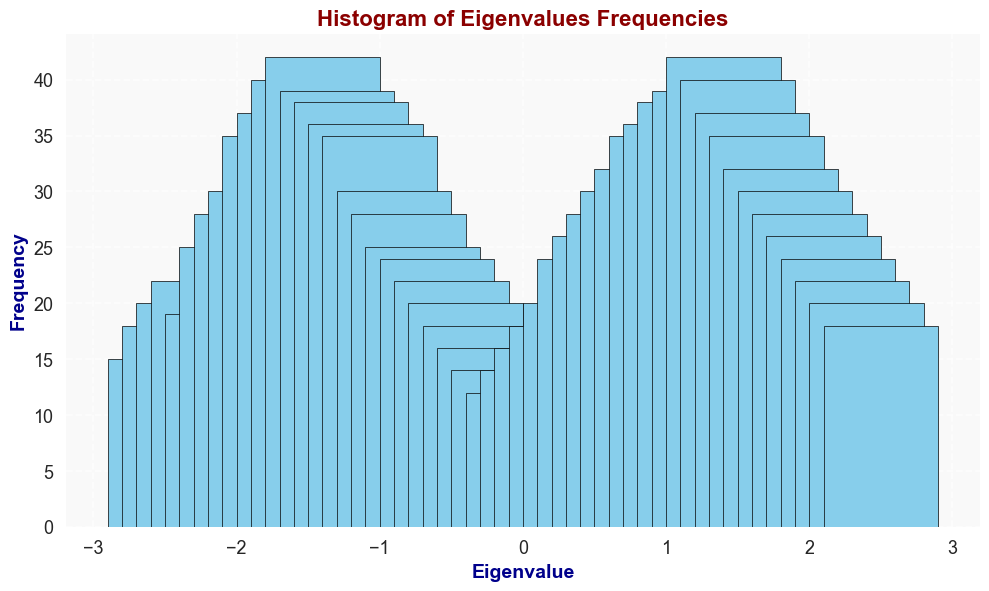what is the most frequent eigenvalue range in the histogram? To find the most frequent eigenvalue range, look for the bar with the highest frequency on the Y-axis. The highest bar corresponds to eigenvalue ranges -1.4 and 1.4, with a frequency of 42.
Answer: -1.4 and 1.4 Which eigenvalue has a frequency closest to 30? To answer this, observe which eigenvalues have bars near 30 on the Y-axis. Eigenvalues -1.8, -0.9, 0.8, and 1.9 each have a frequency of 30.
Answer: -1.8, -0.9, 0.8, 1.9 What's the frequency difference between eigenvalues -2.0 and 2.0? Look at the frequency values for both eigenvalues: -2.0 has a frequency of 25 and 2.0 has a frequency of 28. Subtract the smaller frequency from the larger: 28 - 25 = 3.
Answer: 3 What's the total frequency for eigenvalues in the range 0.0 to 1.0? Identify the bars for eigenvalues 0.0, 0.1, 0.2, 0.3, 0.4, 0.5, 0.6, 0.7, 0.8, 0.9, and 1.0, and then sum their frequencies: 12 + 14 + 16 + 18 + 20 + 24 + 26 + 28 + 30 + 32 + 35 = 255.
Answer: 255 What eigenvalue has its frequency doubled from 0.0? The frequency at 0.0 is 12. Need to find the eigenvalue with a frequency of 24 (double of 12). Eigenvalue -0.6 has a frequency of 24.
Answer: -0.6 Which eigenvalue has equal frequencies on both its positive and negative side? By examining the frequencies of eigenvalues on both sides, eigenvalues 1.7 and -1.7 both have frequencies of 35.
Answer: 1.7 and -1.7 What is the overall trend of frequencies from eigenvalues -2.5 to 2.5? Observe the pattern in the bar heights. Frequency increases from -2.5, peaks around ±1.4, then decreases towards 2.5.
Answer: Increase, then decrease Which eigenvalues have frequencies greater than 40? Check the Y-axis to find bars above the frequency of 40. Eigenvalues -1.4 and 1.4 have frequencies of 42.
Answer: -1.4 and 1.4 What's the average frequency of the eigenvalues between -2.5 and -2.1? Add the frequencies for the eigenvalues -2.5 (15), -2.4 (18), -2.3 (20), -2.2 (22), -2.1 (19) and divide by 5: (15+18+20+22+19)/5 = 18.8.
Answer: 18.8 